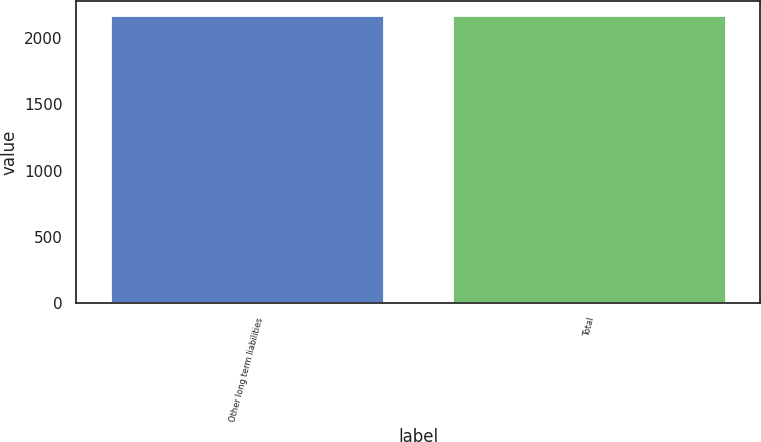Convert chart. <chart><loc_0><loc_0><loc_500><loc_500><bar_chart><fcel>Other long term liabilities<fcel>Total<nl><fcel>2170<fcel>2170.1<nl></chart> 